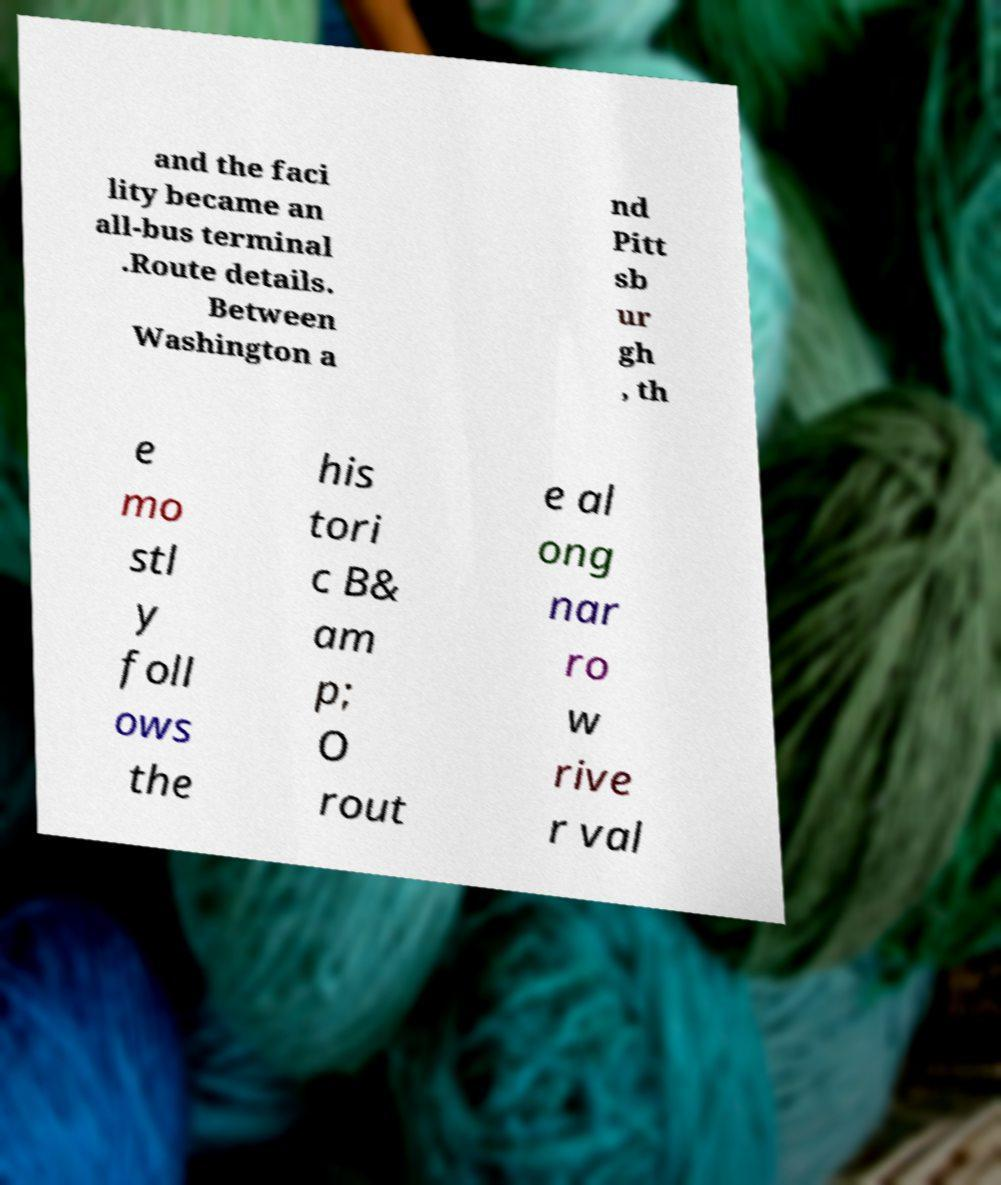Please identify and transcribe the text found in this image. and the faci lity became an all-bus terminal .Route details. Between Washington a nd Pitt sb ur gh , th e mo stl y foll ows the his tori c B& am p; O rout e al ong nar ro w rive r val 